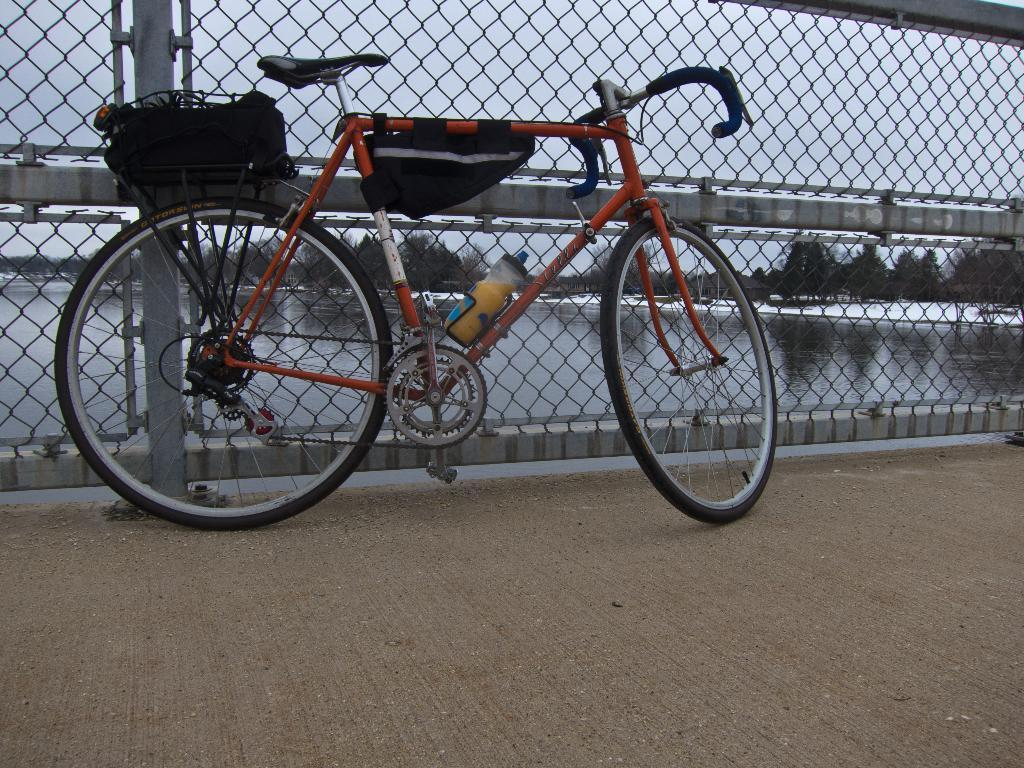What can be seen in the background of the image? In the background of the image, there is a sky, trees, water, and a mesh. What is the main subject of the image? The main subject of the image is a bicycle. What type of surface is visible at the bottom portion of the image? There is a road visible at the bottom portion of the image. What type of pancake is being served on the bicycle in the image? There is no pancake present in the image; the main subject is a bicycle. How does the door in the image relate to the bicycle? There is no door present in the image; the main subject is a bicycle. 